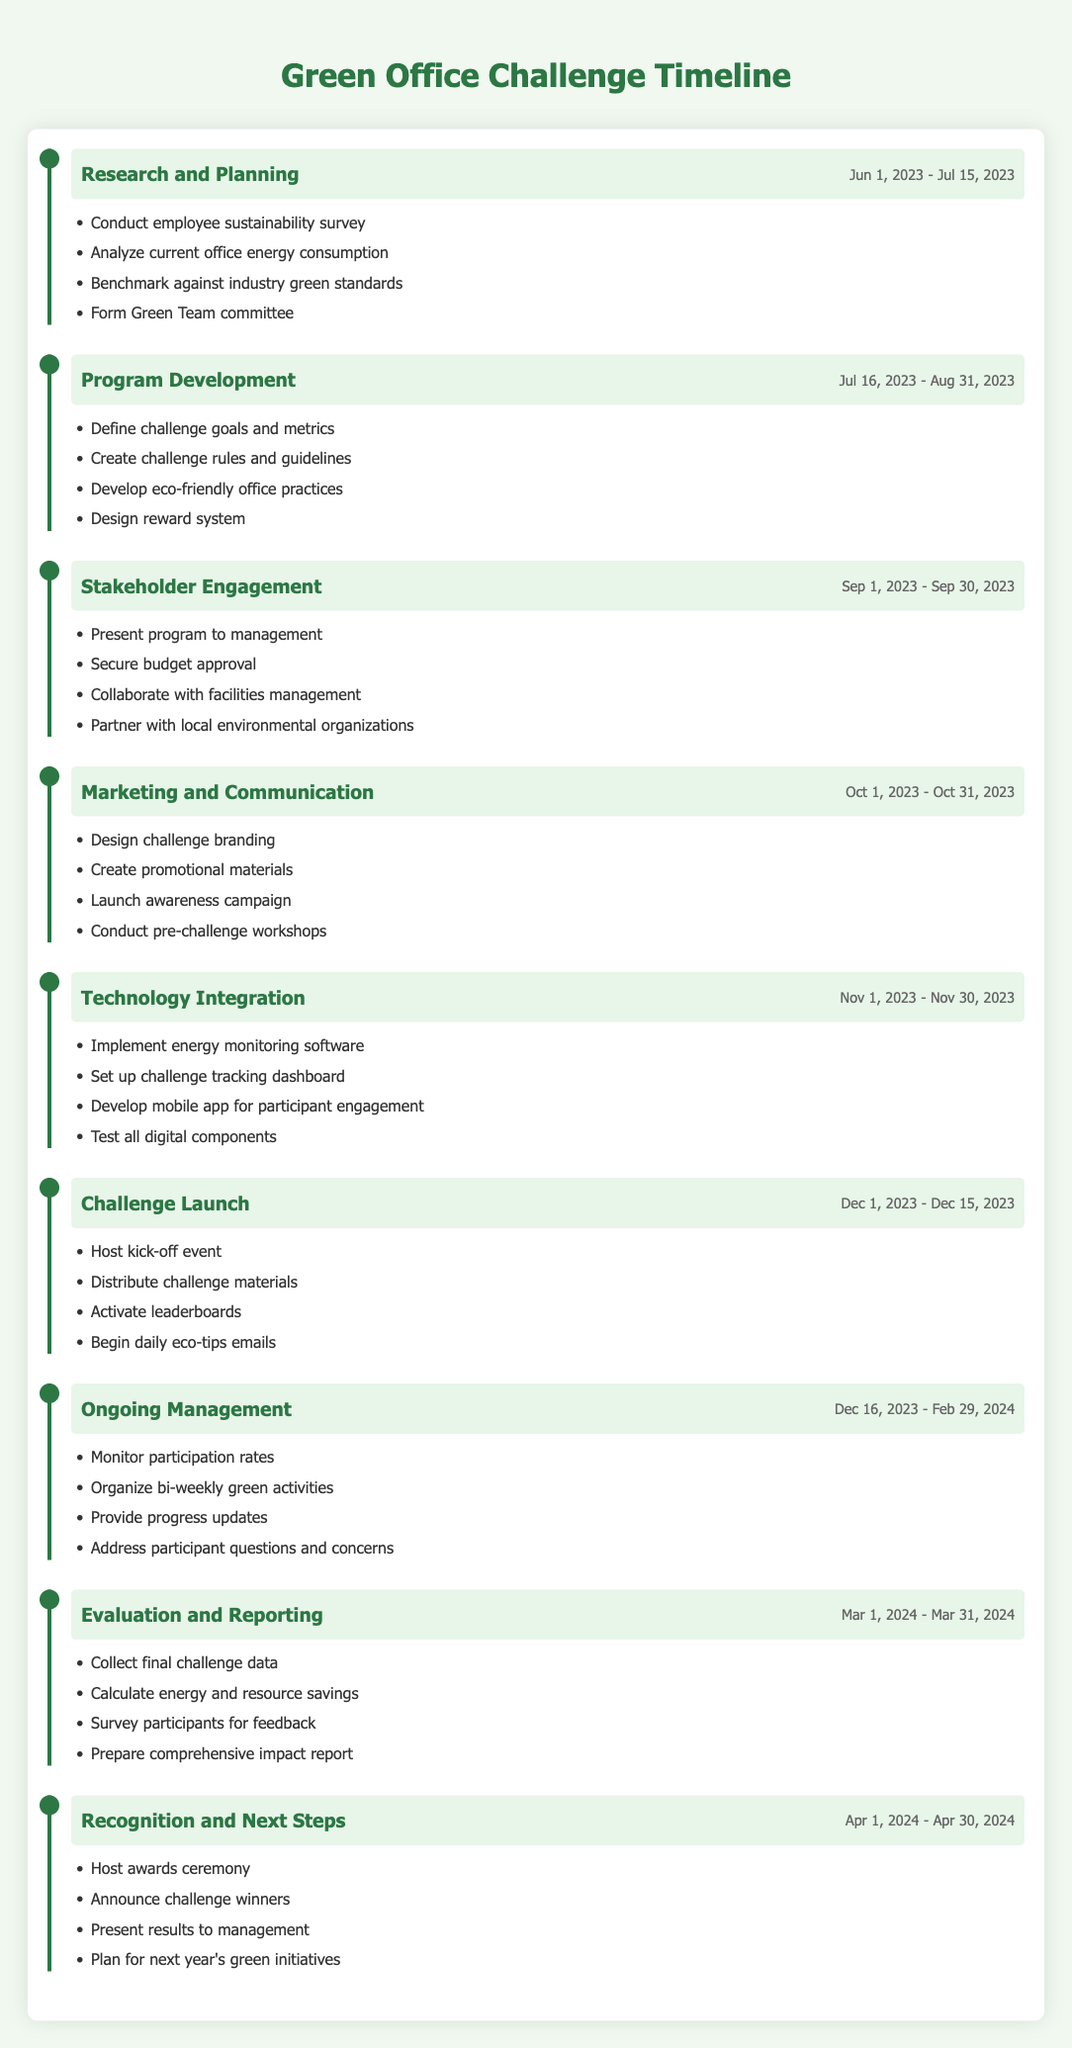What are the start and end dates of the Program Development phase? The Program Development phase starts on July 16, 2023, and ends on August 31, 2023. This information is directly stated in the timeline table under the respective phase.
Answer: July 16, 2023 - August 31, 2023 How many phases are there in total for the Green Office Challenge? By counting the number of phases listed in the timeline table, there are a total of 8 phases: Research and Planning, Program Development, Stakeholder Engagement, Marketing and Communication, Technology Integration, Challenge Launch, Ongoing Management, Evaluation and Reporting, and Recognition and Next Steps.
Answer: 8 Is there a phase that involves designing branding for the challenge? Yes, the phase titled "Marketing and Communication" includes designing challenge branding as one of its activities. The table clearly lists this activity under that phase.
Answer: Yes What is the time duration of the Ongoing Management phase? The Ongoing Management phase lasts from December 16, 2023, to February 29, 2024. To calculate the duration, we find the number of days from the start to the end date, which includes 76 days or about 2.5 months.
Answer: 76 days Which phase includes collaborating with facilities management? The phase called "Stakeholder Engagement" includes the activity of collaborating with facilities management. This detail can be found in the activities list for that phase.
Answer: Stakeholder Engagement If all phases are considered, which phase lasts the longest? The Ongoing Management phase lasts from December 16, 2023, to February 29, 2024, making it the longest phase at 76 days. I find the lengths of all phases, and Ongoing Management has the longest time span.
Answer: Ongoing Management What are the key activities during the Challenge Launch phase? In the Challenge Launch phase, the key activities are hosting a kick-off event, distributing challenge materials, activating leaderboards, and beginning daily eco-tips emails. These are enumerated directly under that phase in the table.
Answer: Host kick-off event, distribute challenge materials, activate leaderboards, begin daily eco-tips emails Are there any phases for which the activities are specific to engaging with external organizations? Yes, the Stakeholder Engagement phase specifically includes partnering with local environmental organizations, indicating engagement with external organizations. This activity is explicitly listed under the phase activities.
Answer: Yes 